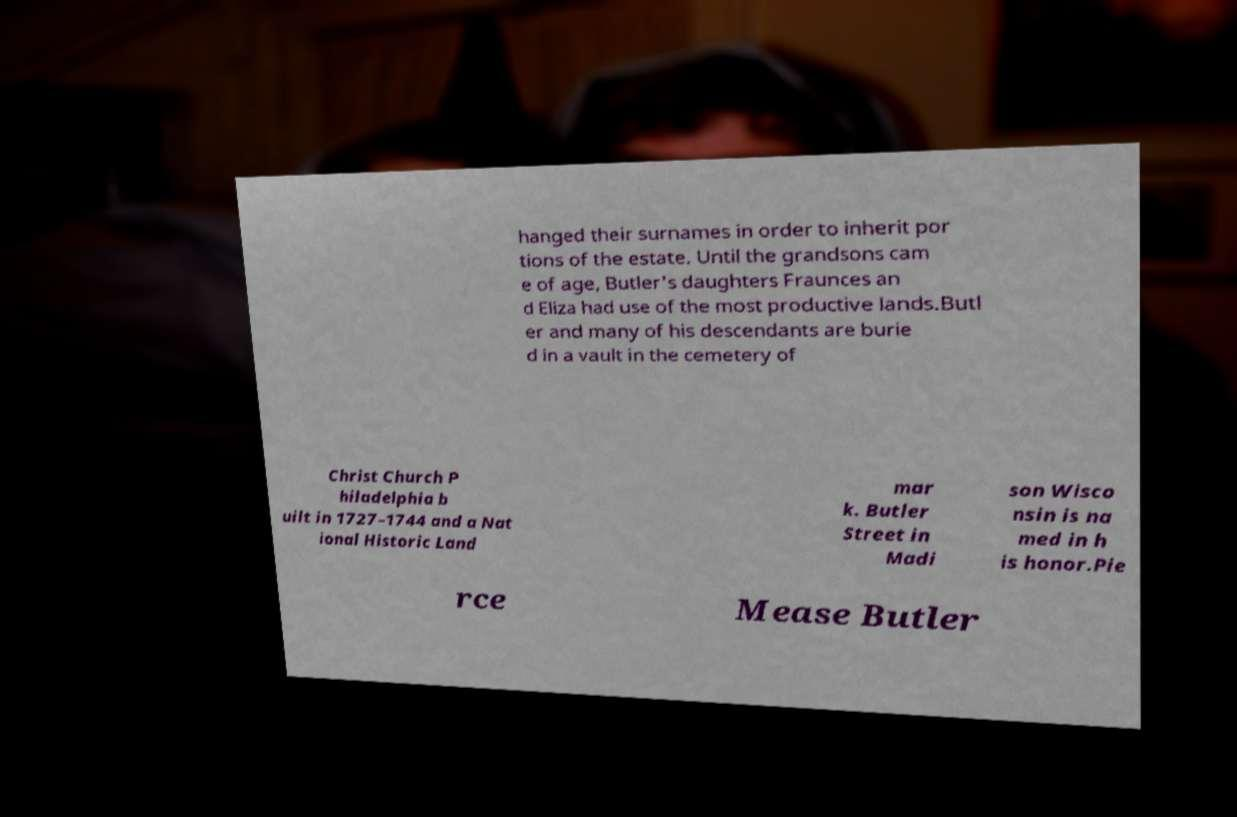For documentation purposes, I need the text within this image transcribed. Could you provide that? hanged their surnames in order to inherit por tions of the estate. Until the grandsons cam e of age, Butler's daughters Fraunces an d Eliza had use of the most productive lands.Butl er and many of his descendants are burie d in a vault in the cemetery of Christ Church P hiladelphia b uilt in 1727–1744 and a Nat ional Historic Land mar k. Butler Street in Madi son Wisco nsin is na med in h is honor.Pie rce Mease Butler 